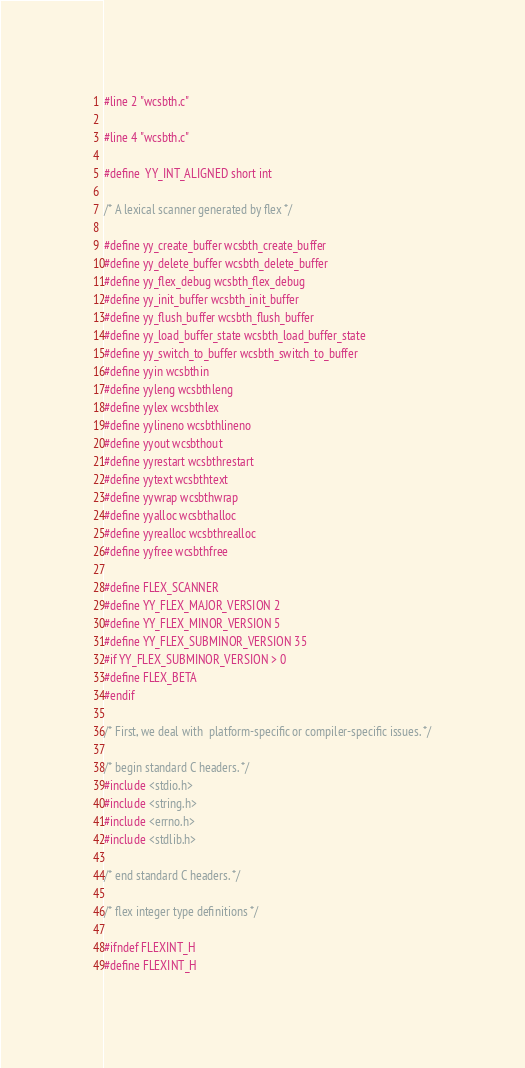<code> <loc_0><loc_0><loc_500><loc_500><_C_>#line 2 "wcsbth.c"

#line 4 "wcsbth.c"

#define  YY_INT_ALIGNED short int

/* A lexical scanner generated by flex */

#define yy_create_buffer wcsbth_create_buffer
#define yy_delete_buffer wcsbth_delete_buffer
#define yy_flex_debug wcsbth_flex_debug
#define yy_init_buffer wcsbth_init_buffer
#define yy_flush_buffer wcsbth_flush_buffer
#define yy_load_buffer_state wcsbth_load_buffer_state
#define yy_switch_to_buffer wcsbth_switch_to_buffer
#define yyin wcsbthin
#define yyleng wcsbthleng
#define yylex wcsbthlex
#define yylineno wcsbthlineno
#define yyout wcsbthout
#define yyrestart wcsbthrestart
#define yytext wcsbthtext
#define yywrap wcsbthwrap
#define yyalloc wcsbthalloc
#define yyrealloc wcsbthrealloc
#define yyfree wcsbthfree

#define FLEX_SCANNER
#define YY_FLEX_MAJOR_VERSION 2
#define YY_FLEX_MINOR_VERSION 5
#define YY_FLEX_SUBMINOR_VERSION 35
#if YY_FLEX_SUBMINOR_VERSION > 0
#define FLEX_BETA
#endif

/* First, we deal with  platform-specific or compiler-specific issues. */

/* begin standard C headers. */
#include <stdio.h>
#include <string.h>
#include <errno.h>
#include <stdlib.h>

/* end standard C headers. */

/* flex integer type definitions */

#ifndef FLEXINT_H
#define FLEXINT_H
</code> 